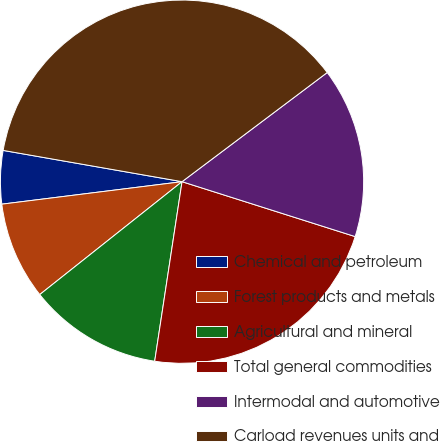Convert chart to OTSL. <chart><loc_0><loc_0><loc_500><loc_500><pie_chart><fcel>Chemical and petroleum<fcel>Forest products and metals<fcel>Agricultural and mineral<fcel>Total general commodities<fcel>Intermodal and automotive<fcel>Carload revenues units and<nl><fcel>4.73%<fcel>8.7%<fcel>11.92%<fcel>22.52%<fcel>15.15%<fcel>36.99%<nl></chart> 